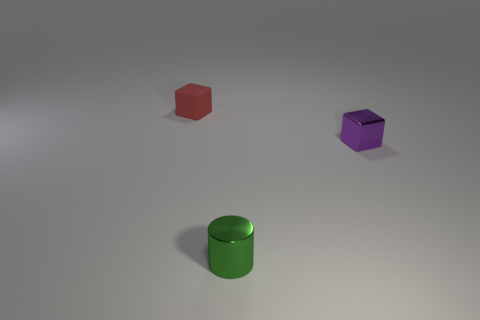Add 2 cyan shiny things. How many objects exist? 5 Subtract all cylinders. How many objects are left? 2 Subtract all rubber blocks. Subtract all tiny metallic cylinders. How many objects are left? 1 Add 1 small metal cylinders. How many small metal cylinders are left? 2 Add 3 green shiny cylinders. How many green shiny cylinders exist? 4 Subtract 0 blue cylinders. How many objects are left? 3 